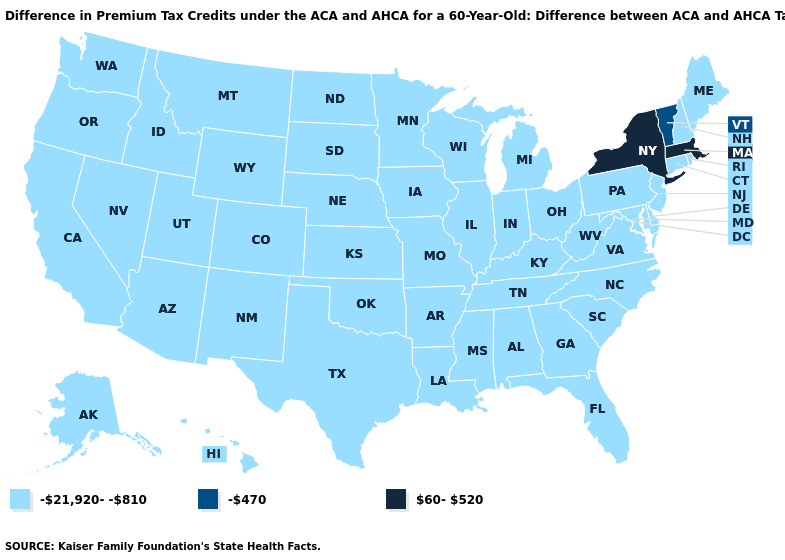Does Pennsylvania have a lower value than Vermont?
Short answer required. Yes. Does Mississippi have the same value as Vermont?
Be succinct. No. Does the first symbol in the legend represent the smallest category?
Give a very brief answer. Yes. Name the states that have a value in the range -470?
Give a very brief answer. Vermont. What is the value of Alabama?
Short answer required. -21,920--810. Does Virginia have a lower value than New York?
Quick response, please. Yes. Which states hav the highest value in the MidWest?
Give a very brief answer. Illinois, Indiana, Iowa, Kansas, Michigan, Minnesota, Missouri, Nebraska, North Dakota, Ohio, South Dakota, Wisconsin. Does Michigan have the same value as New York?
Short answer required. No. Among the states that border Missouri , which have the lowest value?
Write a very short answer. Arkansas, Illinois, Iowa, Kansas, Kentucky, Nebraska, Oklahoma, Tennessee. Name the states that have a value in the range -21,920--810?
Give a very brief answer. Alabama, Alaska, Arizona, Arkansas, California, Colorado, Connecticut, Delaware, Florida, Georgia, Hawaii, Idaho, Illinois, Indiana, Iowa, Kansas, Kentucky, Louisiana, Maine, Maryland, Michigan, Minnesota, Mississippi, Missouri, Montana, Nebraska, Nevada, New Hampshire, New Jersey, New Mexico, North Carolina, North Dakota, Ohio, Oklahoma, Oregon, Pennsylvania, Rhode Island, South Carolina, South Dakota, Tennessee, Texas, Utah, Virginia, Washington, West Virginia, Wisconsin, Wyoming. Does Indiana have a lower value than Florida?
Be succinct. No. Name the states that have a value in the range -21,920--810?
Write a very short answer. Alabama, Alaska, Arizona, Arkansas, California, Colorado, Connecticut, Delaware, Florida, Georgia, Hawaii, Idaho, Illinois, Indiana, Iowa, Kansas, Kentucky, Louisiana, Maine, Maryland, Michigan, Minnesota, Mississippi, Missouri, Montana, Nebraska, Nevada, New Hampshire, New Jersey, New Mexico, North Carolina, North Dakota, Ohio, Oklahoma, Oregon, Pennsylvania, Rhode Island, South Carolina, South Dakota, Tennessee, Texas, Utah, Virginia, Washington, West Virginia, Wisconsin, Wyoming. What is the highest value in the West ?
Quick response, please. -21,920--810. Name the states that have a value in the range -470?
Keep it brief. Vermont. What is the value of New Jersey?
Write a very short answer. -21,920--810. 